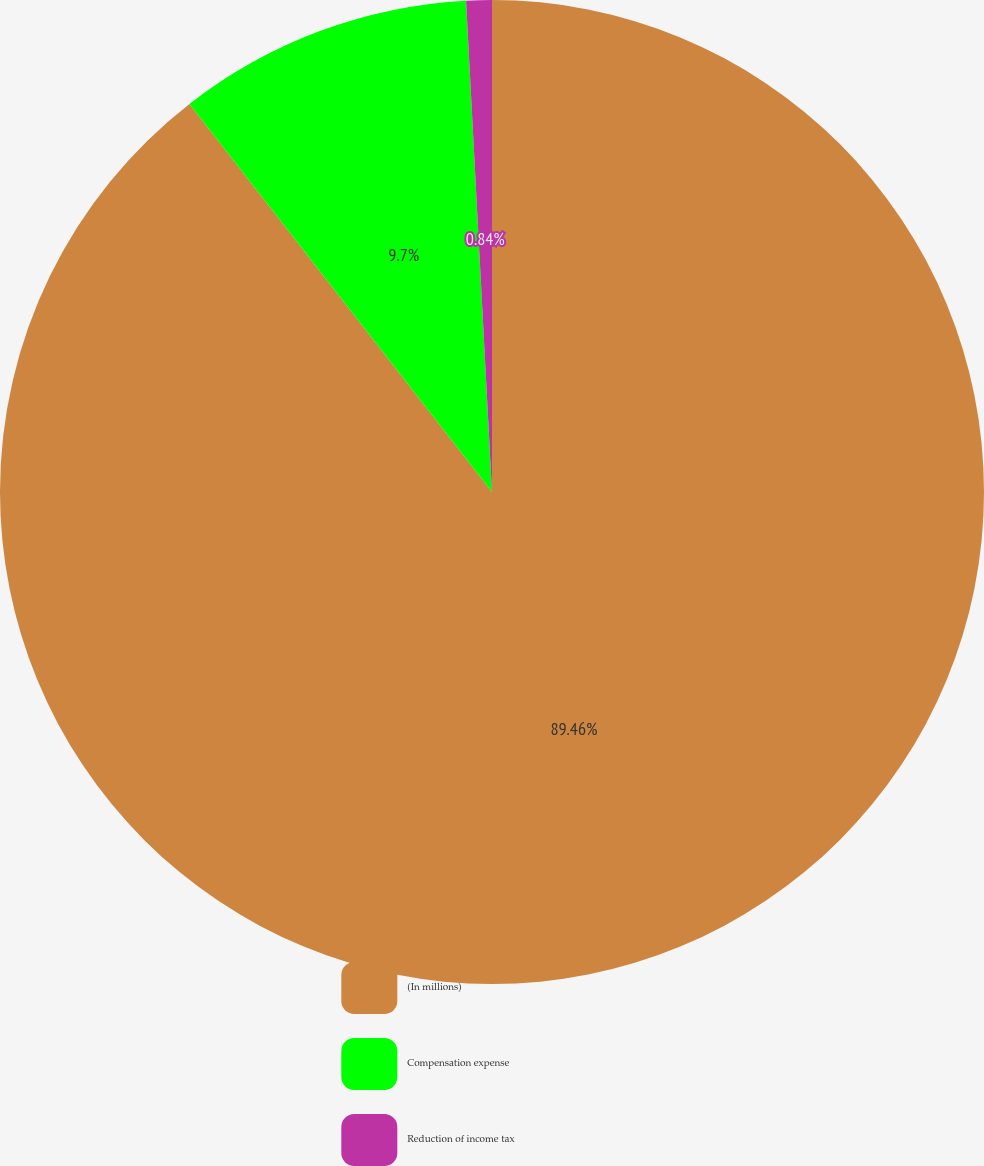<chart> <loc_0><loc_0><loc_500><loc_500><pie_chart><fcel>(In millions)<fcel>Compensation expense<fcel>Reduction of income tax<nl><fcel>89.45%<fcel>9.7%<fcel>0.84%<nl></chart> 